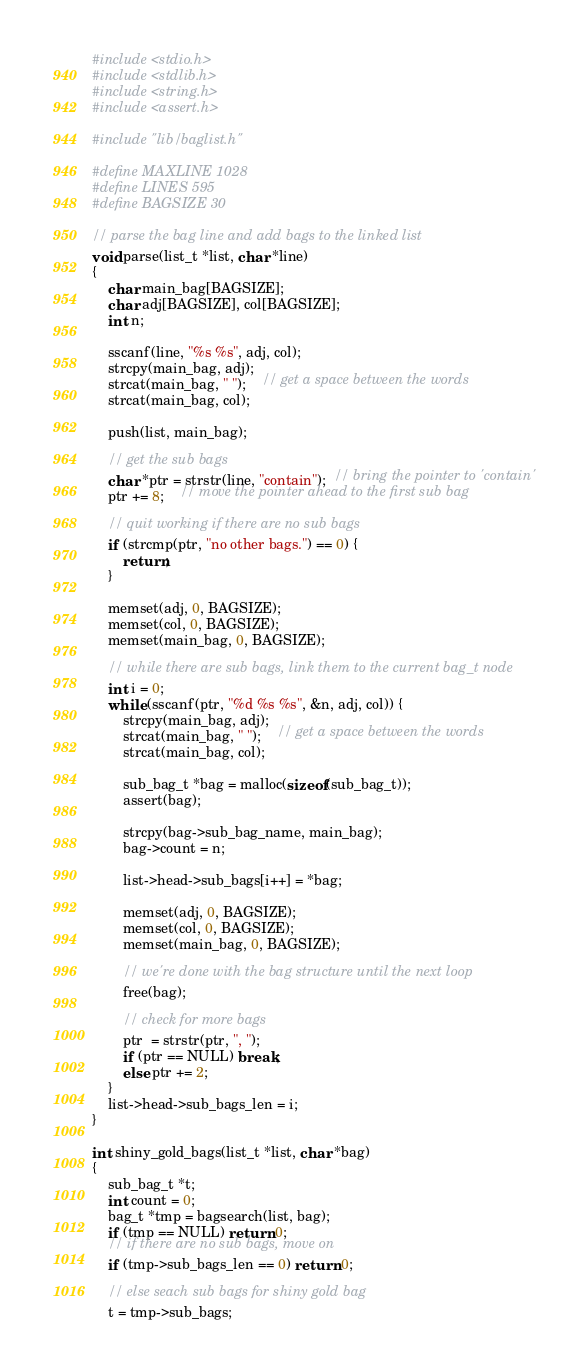<code> <loc_0><loc_0><loc_500><loc_500><_C_>#include <stdio.h>
#include <stdlib.h>
#include <string.h>
#include <assert.h>

#include "lib/baglist.h"

#define MAXLINE 1028
#define LINES 595
#define BAGSIZE 30

// parse the bag line and add bags to the linked list
void parse(list_t *list, char *line)
{
	char main_bag[BAGSIZE];
	char adj[BAGSIZE], col[BAGSIZE];
	int n;

	sscanf(line, "%s %s", adj, col);
	strcpy(main_bag, adj);
	strcat(main_bag, " ");	// get a space between the words
	strcat(main_bag, col);

    push(list, main_bag);

    // get the sub bags
	char *ptr = strstr(line, "contain");  // bring the pointer to 'contain'
	ptr += 8;	// move the pointer ahead to the first sub bag

    // quit working if there are no sub bags
	if (strcmp(ptr, "no other bags.") == 0) {
		return;
	}

	memset(adj, 0, BAGSIZE);
	memset(col, 0, BAGSIZE);
	memset(main_bag, 0, BAGSIZE);

	// while there are sub bags, link them to the current bag_t node
	int i = 0;
	while (sscanf(ptr, "%d %s %s", &n, adj, col)) {
		strcpy(main_bag, adj);
		strcat(main_bag, " ");	// get a space between the words
		strcat(main_bag, col);
		
		sub_bag_t *bag = malloc(sizeof(sub_bag_t));
		assert(bag);
		
		strcpy(bag->sub_bag_name, main_bag);
		bag->count = n;

		list->head->sub_bags[i++] = *bag;

		memset(adj, 0, BAGSIZE);
		memset(col, 0, BAGSIZE);
		memset(main_bag, 0, BAGSIZE);

		// we're done with the bag structure until the next loop
		free(bag);

		// check for more bags
		ptr  = strstr(ptr, ", ");
		if (ptr == NULL) break;
		else ptr += 2;
	}
	list->head->sub_bags_len = i;
}

int shiny_gold_bags(list_t *list, char *bag)
{
	sub_bag_t *t;
	int count = 0;
	bag_t *tmp = bagsearch(list, bag);
	if (tmp == NULL) return 0;
	// if there are no sub bags, move on
	if (tmp->sub_bags_len == 0) return 0;

	// else seach sub bags for shiny gold bag
	t = tmp->sub_bags;</code> 